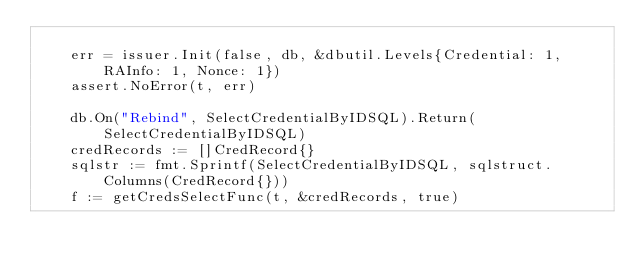Convert code to text. <code><loc_0><loc_0><loc_500><loc_500><_Go_>
	err = issuer.Init(false, db, &dbutil.Levels{Credential: 1, RAInfo: 1, Nonce: 1})
	assert.NoError(t, err)

	db.On("Rebind", SelectCredentialByIDSQL).Return(SelectCredentialByIDSQL)
	credRecords := []CredRecord{}
	sqlstr := fmt.Sprintf(SelectCredentialByIDSQL, sqlstruct.Columns(CredRecord{}))
	f := getCredsSelectFunc(t, &credRecords, true)</code> 